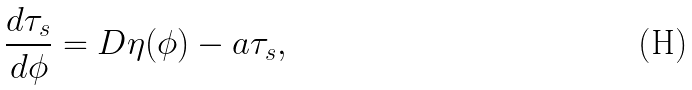Convert formula to latex. <formula><loc_0><loc_0><loc_500><loc_500>\frac { d \tau _ { s } } { d \phi } = D \eta ( \phi ) - a \tau _ { s } ,</formula> 